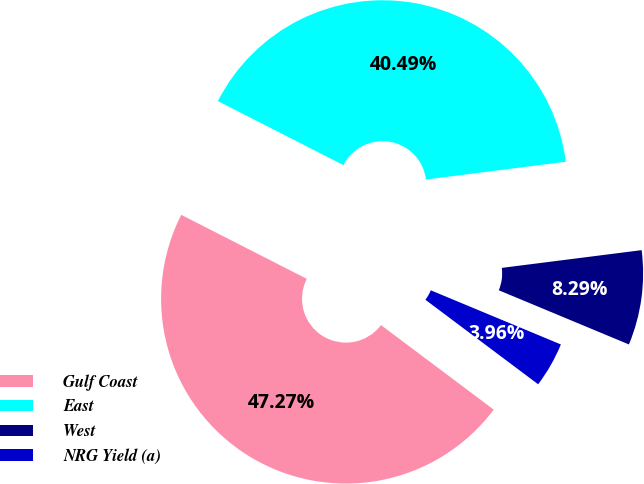Convert chart. <chart><loc_0><loc_0><loc_500><loc_500><pie_chart><fcel>Gulf Coast<fcel>East<fcel>West<fcel>NRG Yield (a)<nl><fcel>47.27%<fcel>40.49%<fcel>8.29%<fcel>3.96%<nl></chart> 